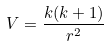Convert formula to latex. <formula><loc_0><loc_0><loc_500><loc_500>V = \frac { k ( k + 1 ) } { r ^ { 2 } }</formula> 